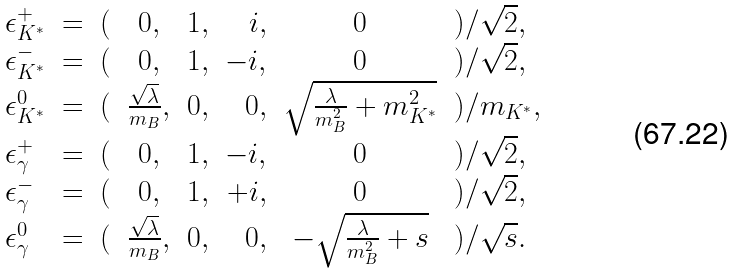Convert formula to latex. <formula><loc_0><loc_0><loc_500><loc_500>\begin{array} { l c l c c r c l } \epsilon _ { K ^ { * } } ^ { + } & = & ( & 0 , & 1 , & i , & 0 & ) / \sqrt { 2 } , \\ \epsilon _ { K ^ { * } } ^ { - } & = & ( & 0 , & 1 , & - i , & 0 & ) / \sqrt { 2 } , \\ \epsilon _ { K ^ { * } } ^ { 0 } & = & ( & \frac { \sqrt { \lambda } } { m _ { B } } , & 0 , & 0 , & \sqrt { \frac { \lambda } { m _ { B } ^ { 2 } } + m _ { K ^ { * } } ^ { 2 } } & ) / m _ { K ^ { * } } , \\ \epsilon _ { \gamma } ^ { + } & = & ( & 0 , & 1 , & - i , & 0 & ) / \sqrt { 2 } , \\ \epsilon _ { \gamma } ^ { - } & = & ( & 0 , & 1 , & + i , & 0 & ) / \sqrt { 2 } , \\ \epsilon _ { \gamma } ^ { 0 } & = & ( & \frac { \sqrt { \lambda } } { m _ { B } } , & 0 , & 0 , & - \sqrt { \frac { \lambda } { m _ { B } ^ { 2 } } + s } & ) / \sqrt { s } . \end{array}</formula> 